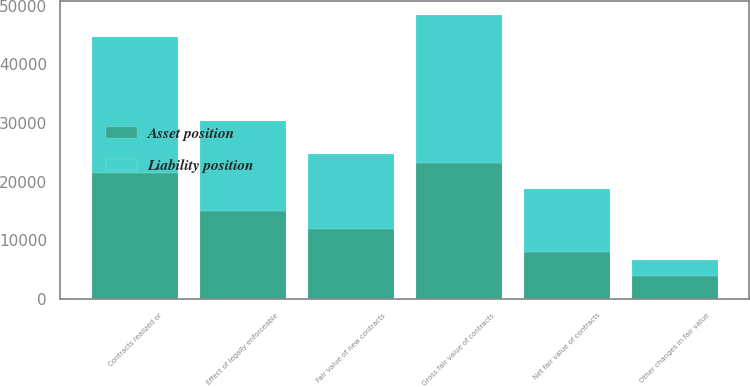Convert chart to OTSL. <chart><loc_0><loc_0><loc_500><loc_500><stacked_bar_chart><ecel><fcel>Net fair value of contracts<fcel>Effect of legally enforceable<fcel>Gross fair value of contracts<fcel>Contracts realized or<fcel>Fair value of new contracts<fcel>Other changes in fair value<nl><fcel>Asset position<fcel>7934<fcel>15082<fcel>23210<fcel>21406<fcel>11955<fcel>3998<nl><fcel>Liability position<fcel>10745<fcel>15318<fcel>25247<fcel>23246<fcel>12709<fcel>2647<nl></chart> 